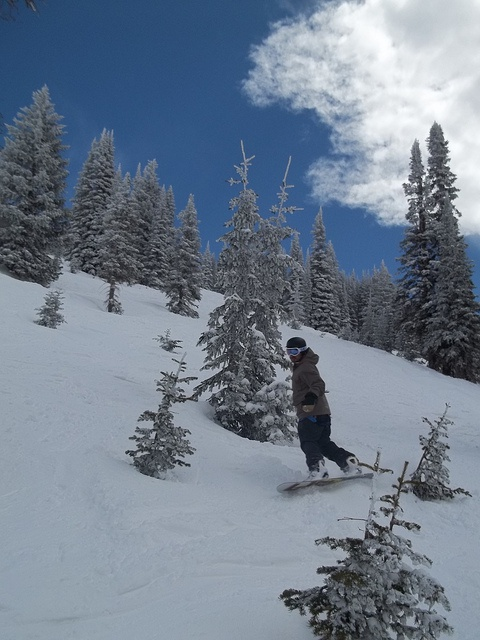Describe the objects in this image and their specific colors. I can see people in darkblue, black, gray, and darkgray tones, snowboard in darkblue and gray tones, and skis in darkblue, gray, and black tones in this image. 